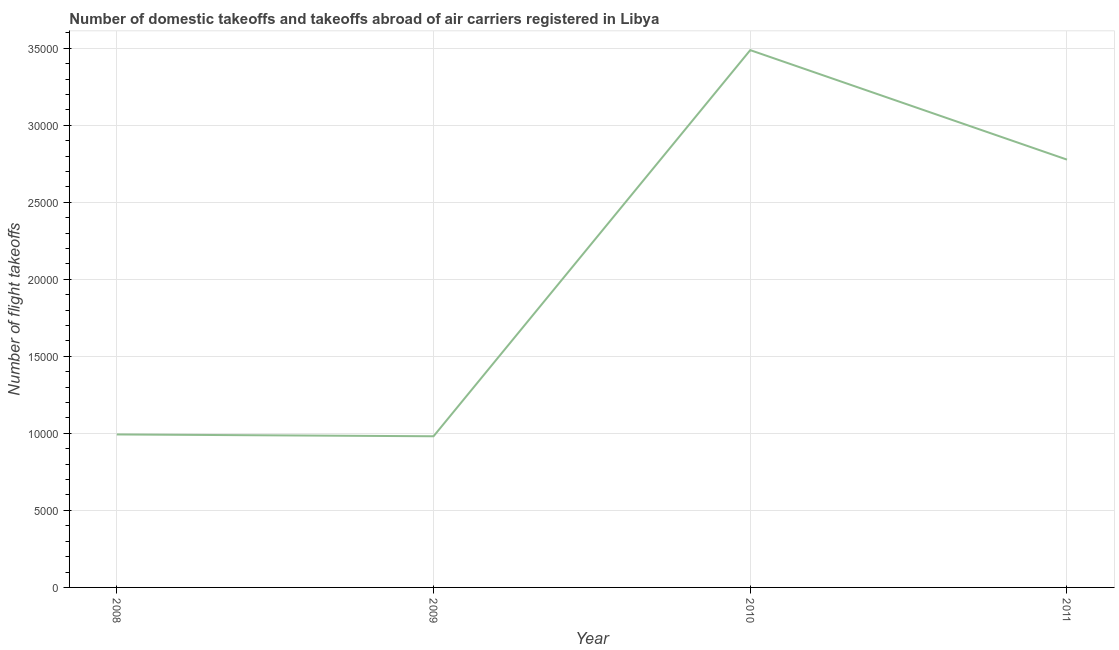What is the number of flight takeoffs in 2008?
Your answer should be very brief. 9930. Across all years, what is the maximum number of flight takeoffs?
Provide a succinct answer. 3.49e+04. Across all years, what is the minimum number of flight takeoffs?
Offer a terse response. 9812. In which year was the number of flight takeoffs maximum?
Your answer should be very brief. 2010. In which year was the number of flight takeoffs minimum?
Your response must be concise. 2009. What is the sum of the number of flight takeoffs?
Provide a short and direct response. 8.24e+04. What is the difference between the number of flight takeoffs in 2008 and 2010?
Offer a very short reply. -2.49e+04. What is the average number of flight takeoffs per year?
Your response must be concise. 2.06e+04. What is the median number of flight takeoffs?
Your answer should be compact. 1.89e+04. Do a majority of the years between 2010 and 2011 (inclusive) have number of flight takeoffs greater than 12000 ?
Offer a very short reply. Yes. What is the ratio of the number of flight takeoffs in 2009 to that in 2010?
Ensure brevity in your answer.  0.28. Is the number of flight takeoffs in 2009 less than that in 2011?
Provide a succinct answer. Yes. Is the difference between the number of flight takeoffs in 2009 and 2010 greater than the difference between any two years?
Provide a succinct answer. Yes. What is the difference between the highest and the second highest number of flight takeoffs?
Keep it short and to the point. 7107.58. Is the sum of the number of flight takeoffs in 2008 and 2010 greater than the maximum number of flight takeoffs across all years?
Provide a short and direct response. Yes. What is the difference between the highest and the lowest number of flight takeoffs?
Provide a short and direct response. 2.51e+04. In how many years, is the number of flight takeoffs greater than the average number of flight takeoffs taken over all years?
Your response must be concise. 2. Does the graph contain any zero values?
Ensure brevity in your answer.  No. What is the title of the graph?
Your response must be concise. Number of domestic takeoffs and takeoffs abroad of air carriers registered in Libya. What is the label or title of the Y-axis?
Make the answer very short. Number of flight takeoffs. What is the Number of flight takeoffs in 2008?
Your answer should be very brief. 9930. What is the Number of flight takeoffs in 2009?
Provide a succinct answer. 9812. What is the Number of flight takeoffs in 2010?
Give a very brief answer. 3.49e+04. What is the Number of flight takeoffs of 2011?
Your answer should be very brief. 2.78e+04. What is the difference between the Number of flight takeoffs in 2008 and 2009?
Provide a succinct answer. 118. What is the difference between the Number of flight takeoffs in 2008 and 2010?
Your answer should be very brief. -2.49e+04. What is the difference between the Number of flight takeoffs in 2008 and 2011?
Offer a very short reply. -1.78e+04. What is the difference between the Number of flight takeoffs in 2009 and 2010?
Your answer should be compact. -2.51e+04. What is the difference between the Number of flight takeoffs in 2009 and 2011?
Keep it short and to the point. -1.80e+04. What is the difference between the Number of flight takeoffs in 2010 and 2011?
Your answer should be very brief. 7107.58. What is the ratio of the Number of flight takeoffs in 2008 to that in 2009?
Your answer should be very brief. 1.01. What is the ratio of the Number of flight takeoffs in 2008 to that in 2010?
Your answer should be compact. 0.28. What is the ratio of the Number of flight takeoffs in 2008 to that in 2011?
Your answer should be very brief. 0.36. What is the ratio of the Number of flight takeoffs in 2009 to that in 2010?
Your answer should be compact. 0.28. What is the ratio of the Number of flight takeoffs in 2009 to that in 2011?
Provide a short and direct response. 0.35. What is the ratio of the Number of flight takeoffs in 2010 to that in 2011?
Offer a terse response. 1.26. 